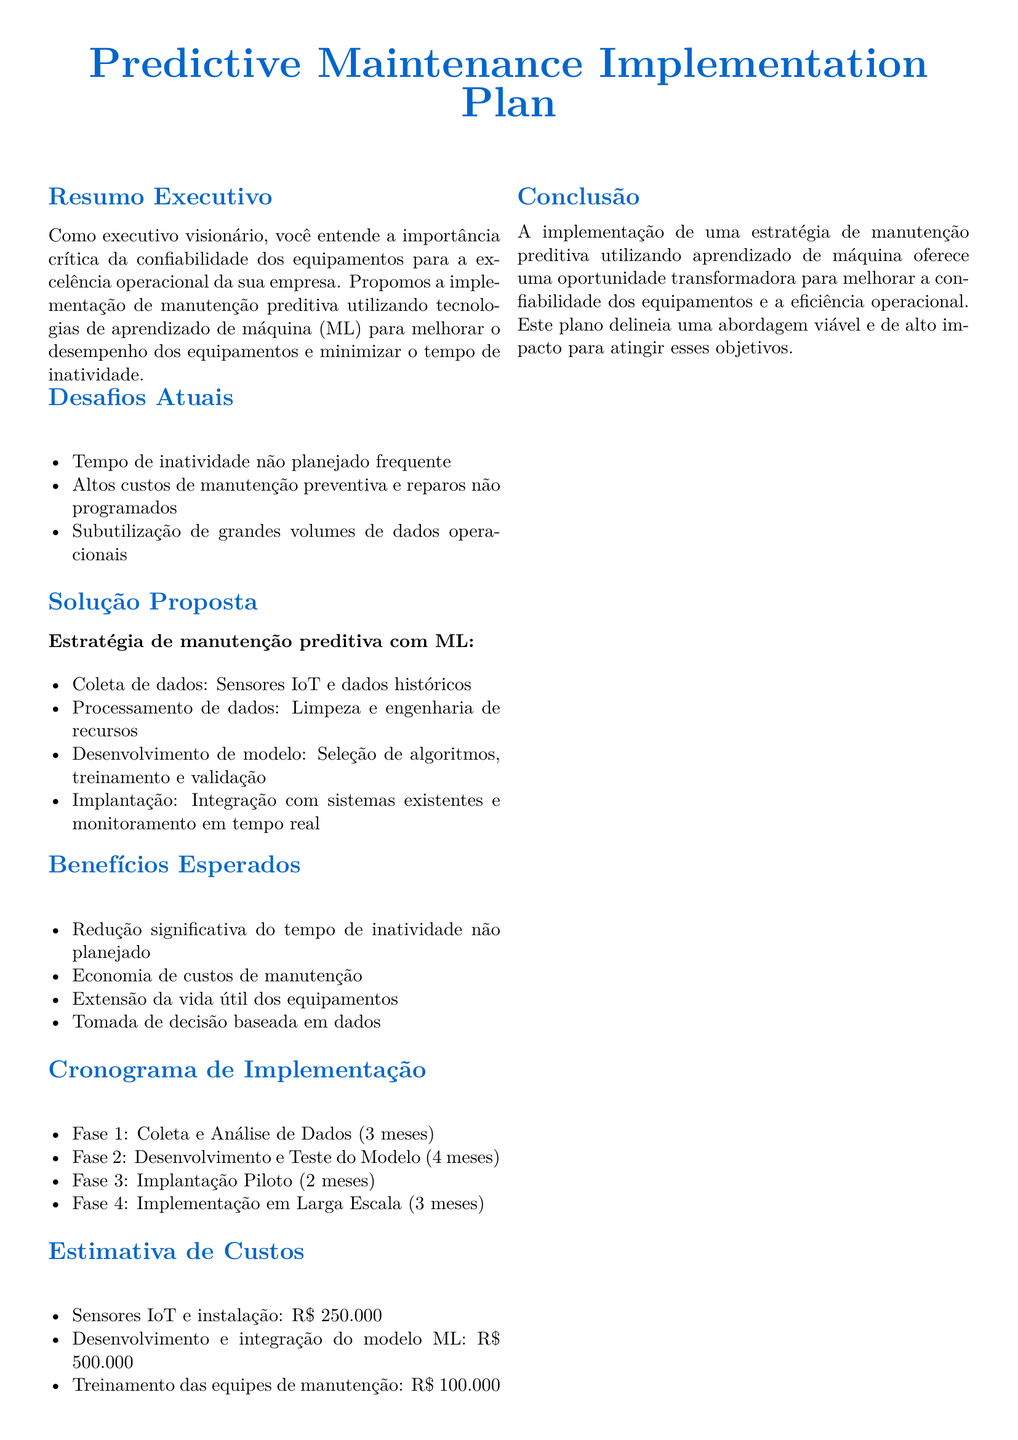qual é o foco principal do plano? O foco principal do plano é a implementação de manutenção preditiva utilizando tecnologias de aprendizado de máquina para melhorar o desempenho dos equipamentos.
Answer: manutenção preditiva quais são os desafios atuais destacados no documento? Os desafios atuais destacados no documento incluem tempo de inatividade não planejado frequente, altos custos de manutenção e subutilização de dados operacionais.
Answer: tempo de inatividade não planejado frequente, altos custos de manutenção, subutilização de dados qual é a duração da fase de coleta e análise de dados? A duração da fase de coleta e análise de dados é especificada no cronograma de implementação como 3 meses.
Answer: 3 meses qual é o custo estimado para sensores IoT e instalação? O custo estimado para sensores IoT e instalação é mencionado na seção de estimativa de custos.
Answer: R$ 250.000 quais são os benefícios esperados da implementação proposta? Os benefícios esperados incluem redução do tempo de inatividade, economia de custos de manutenção e extensão da vida útil dos equipamentos.
Answer: redução do tempo de inatividade, economia de custos de manutenção, extensão da vida útil dos equipamentos quais são as fases de implantação do plano? As fases de implantação incluem coleta e análise de dados, desenvolvimento e teste do modelo, implantação piloto e implementação em larga escala.
Answer: coleta e análise de dados, desenvolvimento e teste do modelo, implantação piloto, implementação em larga escala qual é a estimativa total de custos para o desenvolvimento e a integração do modelo ML? A estimativa total de custos para o desenvolvimento e a integração é fornecida na seção de estimativa de custos e deve ser somada.
Answer: R$ 500.000 quem é o público alvo do resumo executivo? O público alvo do resumo executivo são executivos que entendem a importância da confiabilidade dos equipamentos para a excelência operacional.
Answer: executivos 